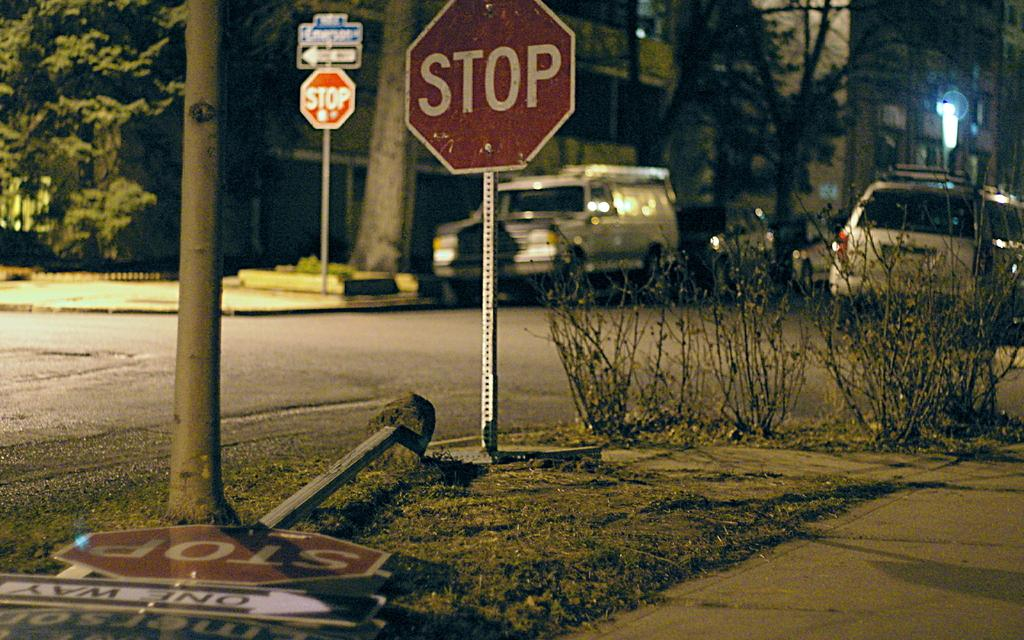Provide a one-sentence caption for the provided image. A new stop sign stands next to a knocked over one with a One Way sign attached to it. 